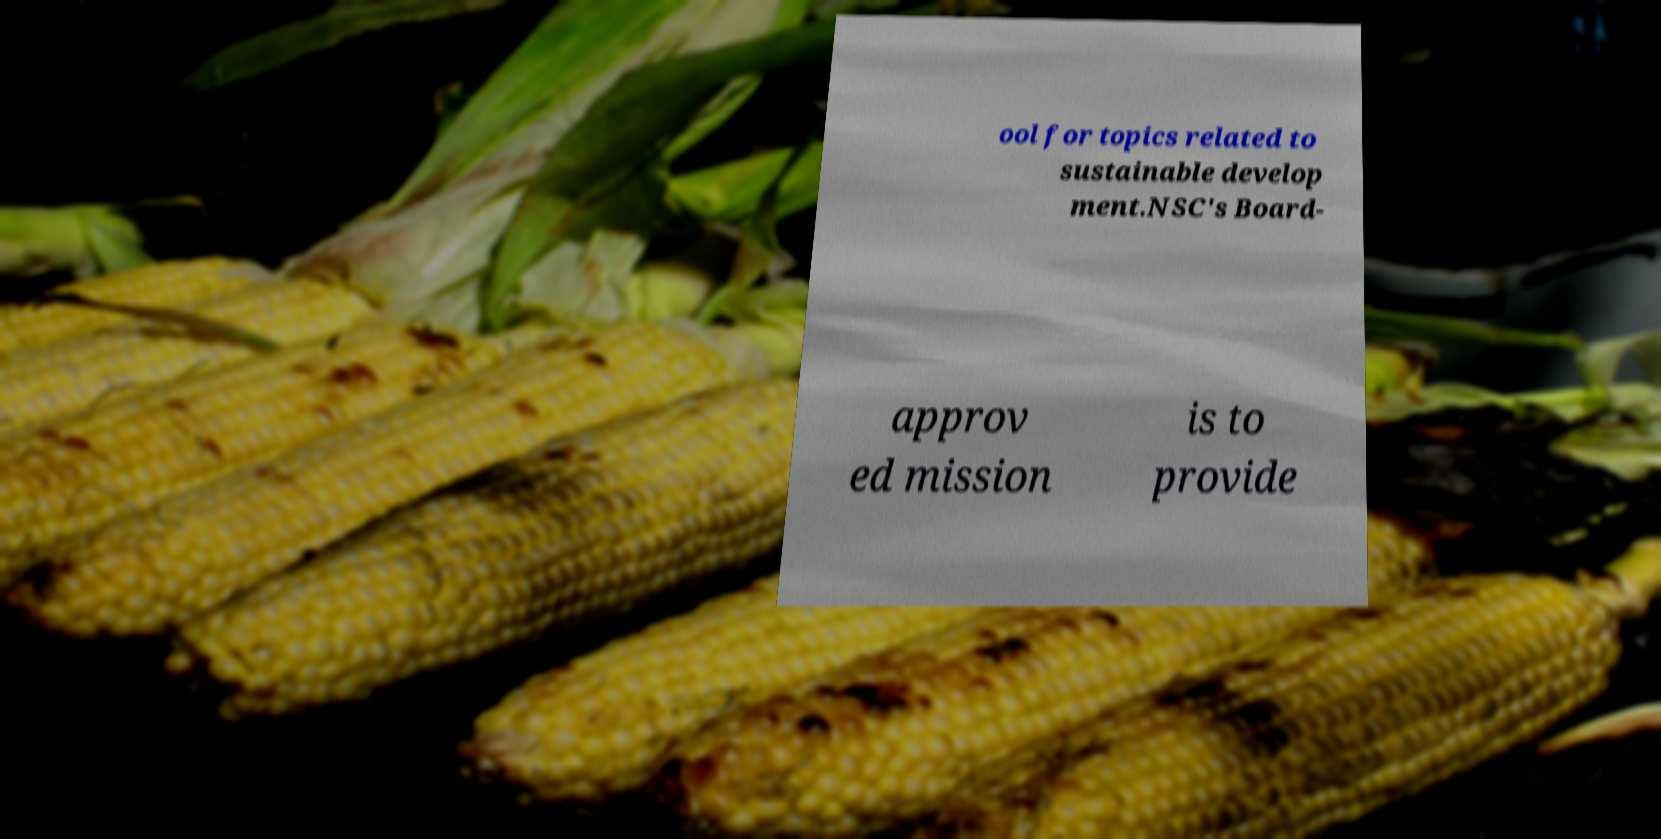Can you read and provide the text displayed in the image?This photo seems to have some interesting text. Can you extract and type it out for me? ool for topics related to sustainable develop ment.NSC's Board- approv ed mission is to provide 